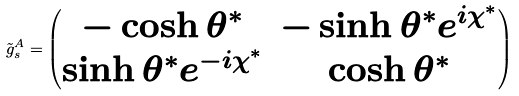Convert formula to latex. <formula><loc_0><loc_0><loc_500><loc_500>\tilde { g } _ { s } ^ { A } = \begin{pmatrix} - \cosh \theta ^ { * } & - \sinh \theta ^ { * } e ^ { i \chi ^ { * } } \\ \sinh \theta ^ { * } e ^ { - i \chi ^ { * } } & \cosh \theta ^ { * } \end{pmatrix}</formula> 